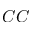<formula> <loc_0><loc_0><loc_500><loc_500>C C</formula> 